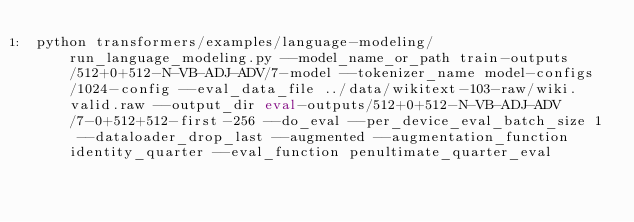<code> <loc_0><loc_0><loc_500><loc_500><_Bash_>python transformers/examples/language-modeling/run_language_modeling.py --model_name_or_path train-outputs/512+0+512-N-VB-ADJ-ADV/7-model --tokenizer_name model-configs/1024-config --eval_data_file ../data/wikitext-103-raw/wiki.valid.raw --output_dir eval-outputs/512+0+512-N-VB-ADJ-ADV/7-0+512+512-first-256 --do_eval --per_device_eval_batch_size 1 --dataloader_drop_last --augmented --augmentation_function identity_quarter --eval_function penultimate_quarter_eval</code> 